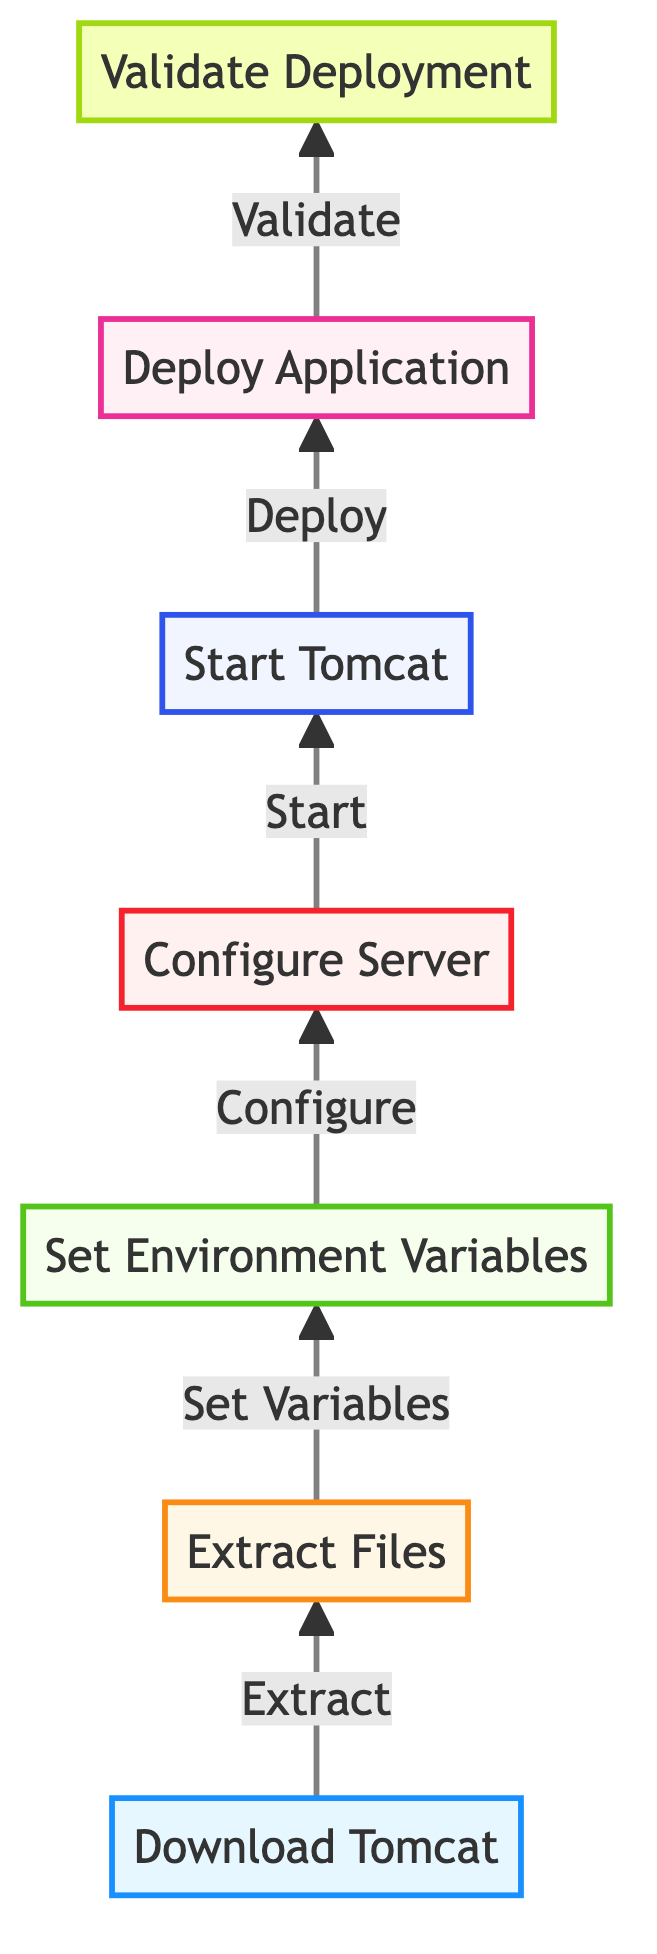What is the first step in setting up a Tomcat server? The first step in the diagram is "Download Tomcat". It is the initial action represented at the bottom of the flow chart, making it the starting point.
Answer: Download Tomcat How many total steps are involved in the diagram? The diagram lists seven distinct steps that detail the process of setting up a Tomcat server, from downloading to validating deployment.
Answer: Seven What node follows "Start Tomcat" in the flow? After "Start Tomcat", the next node in the flow is "Deploy Application". The arrows indicate the sequence of actions, confirming this as the immediate subsequent step.
Answer: Deploy Application What is the last step in the setup process? The final step is "Validate Deployment". This is the topmost node in the flow, indicating it is the concluding action of the process.
Answer: Validate Deployment What is the relationship between "Extract Files" and "Set Environment Variables"? "Extract Files" directly leads to "Set Environment Variables", as indicated by the arrow connecting the two. This shows that after extracting the files, the next action is to set the environment variables.
Answer: Set Variables What is the cumulative sequence from downloading to validating? The sequence begins with "Download Tomcat", followed by "Extract Files", "Set Environment Variables", "Configure Server", "Start Tomcat", "Deploy Application", and ends with "Validate Deployment". This represents the complete flow from the first action to the last.
Answer: Download Tomcat → Extract Files → Set Environment Variables → Configure Server → Start Tomcat → Deploy Application → Validate Deployment Which step is indicated to configure server parameters? The step for configuring server parameters is "Configure Server". This node specifically addresses the edits needed in the server configuration file where these parameters can be set.
Answer: Configure Server 